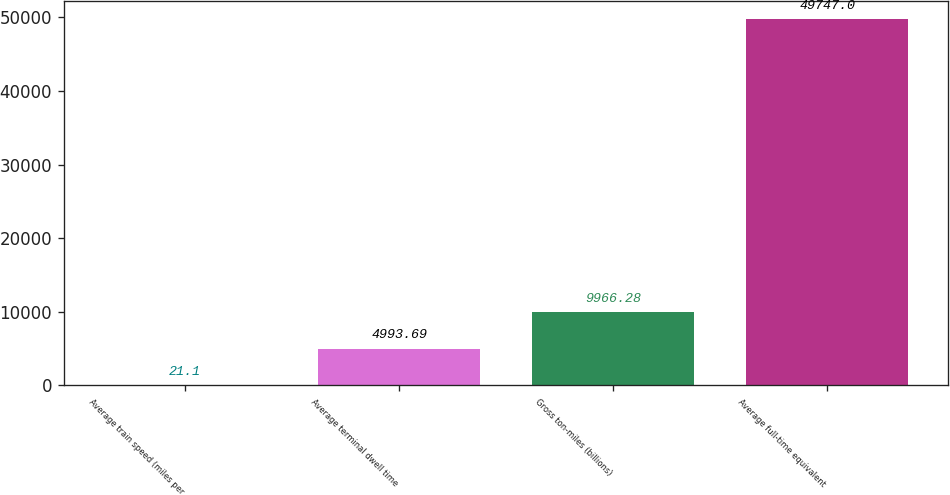<chart> <loc_0><loc_0><loc_500><loc_500><bar_chart><fcel>Average train speed (miles per<fcel>Average terminal dwell time<fcel>Gross ton-miles (billions)<fcel>Average full-time equivalent<nl><fcel>21.1<fcel>4993.69<fcel>9966.28<fcel>49747<nl></chart> 